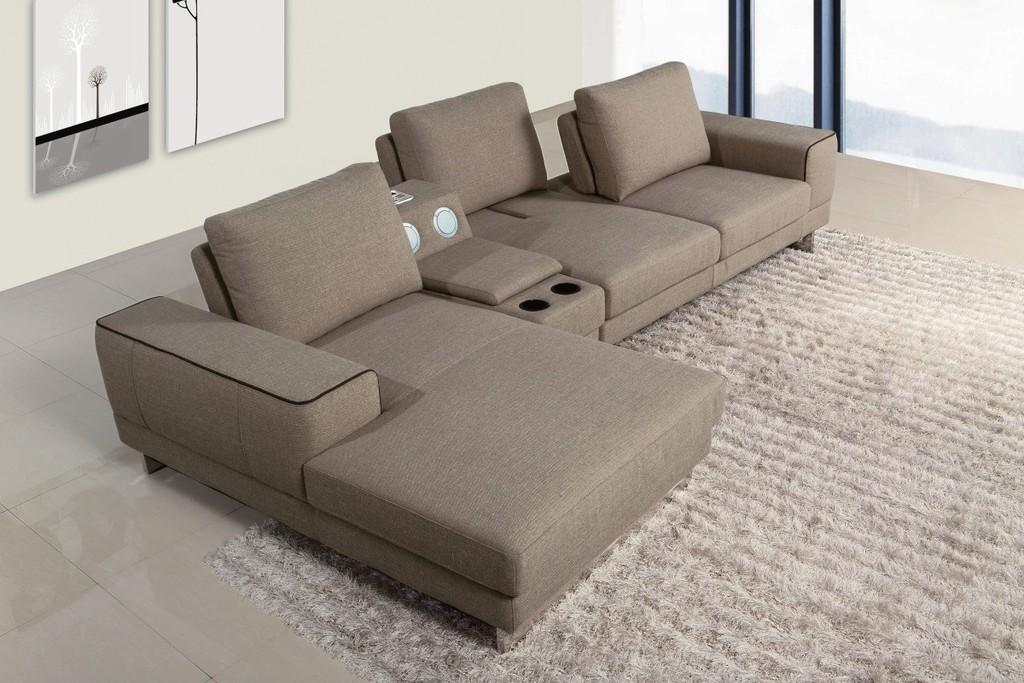What type of furniture is on the carpet in the image? There is a sofa set on a carpet in the image. What can be seen in the background of the image? There is a wall in the background of the image. What is hanging on the wall in the image? There is a photo frame on the wall in the image. What type of door is visible in the image? There is a glass door in the image. What religious symbols are present on the sofa in the image? There are no religious symbols present on the sofa in the image. 